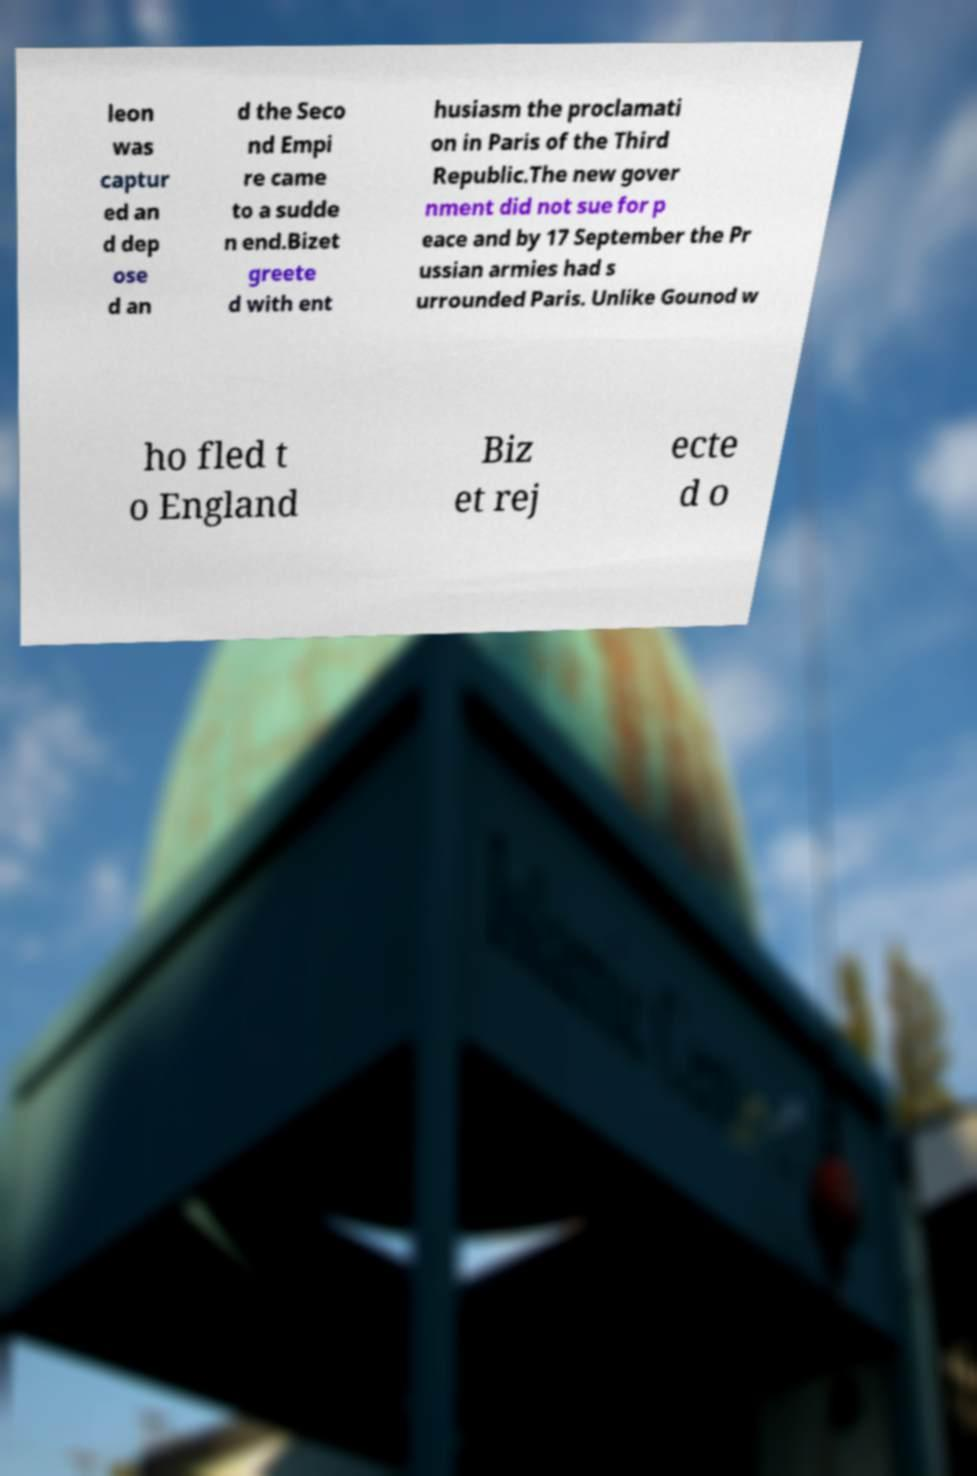I need the written content from this picture converted into text. Can you do that? leon was captur ed an d dep ose d an d the Seco nd Empi re came to a sudde n end.Bizet greete d with ent husiasm the proclamati on in Paris of the Third Republic.The new gover nment did not sue for p eace and by 17 September the Pr ussian armies had s urrounded Paris. Unlike Gounod w ho fled t o England Biz et rej ecte d o 